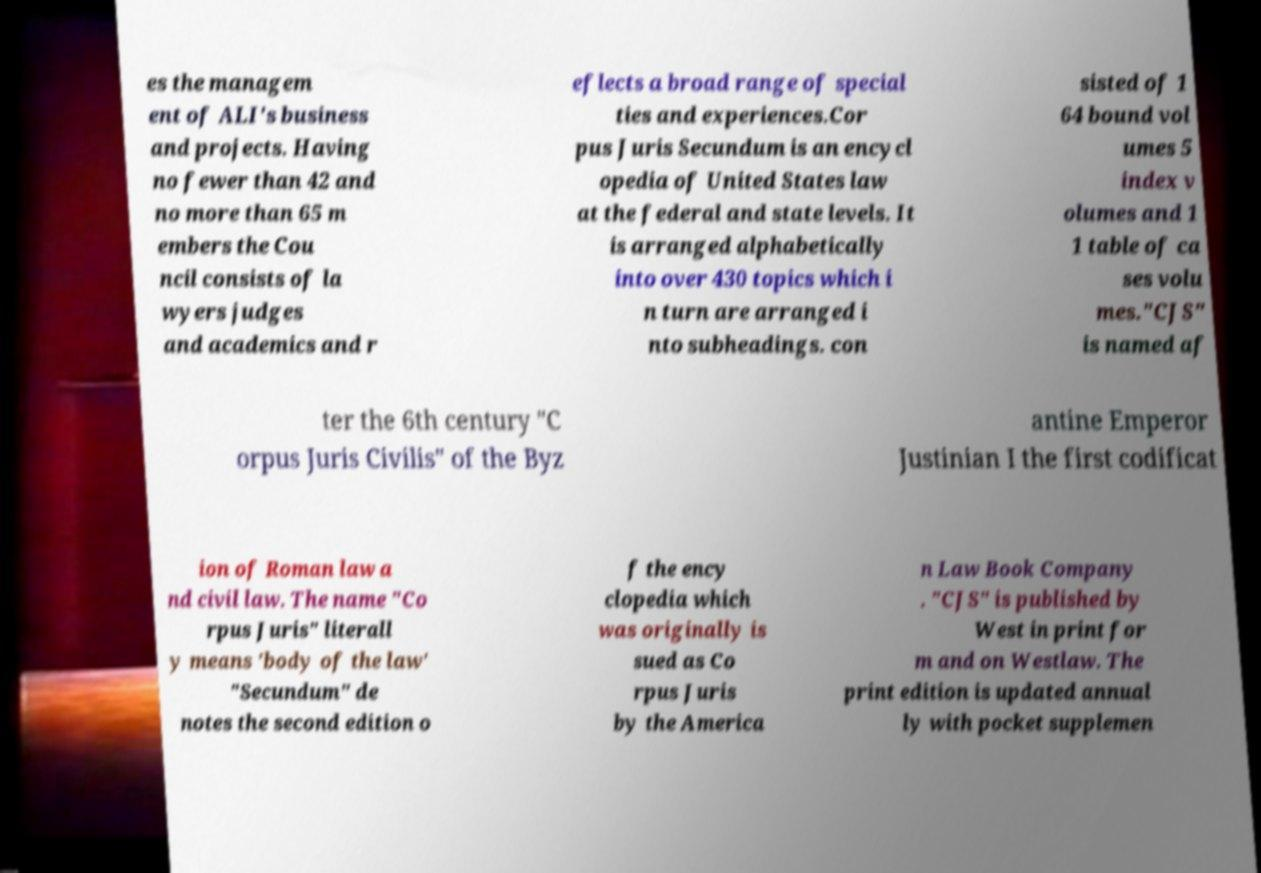What messages or text are displayed in this image? I need them in a readable, typed format. es the managem ent of ALI's business and projects. Having no fewer than 42 and no more than 65 m embers the Cou ncil consists of la wyers judges and academics and r eflects a broad range of special ties and experiences.Cor pus Juris Secundum is an encycl opedia of United States law at the federal and state levels. It is arranged alphabetically into over 430 topics which i n turn are arranged i nto subheadings. con sisted of 1 64 bound vol umes 5 index v olumes and 1 1 table of ca ses volu mes."CJS" is named af ter the 6th century "C orpus Juris Civilis" of the Byz antine Emperor Justinian I the first codificat ion of Roman law a nd civil law. The name "Co rpus Juris" literall y means 'body of the law' "Secundum" de notes the second edition o f the ency clopedia which was originally is sued as Co rpus Juris by the America n Law Book Company . "CJS" is published by West in print for m and on Westlaw. The print edition is updated annual ly with pocket supplemen 